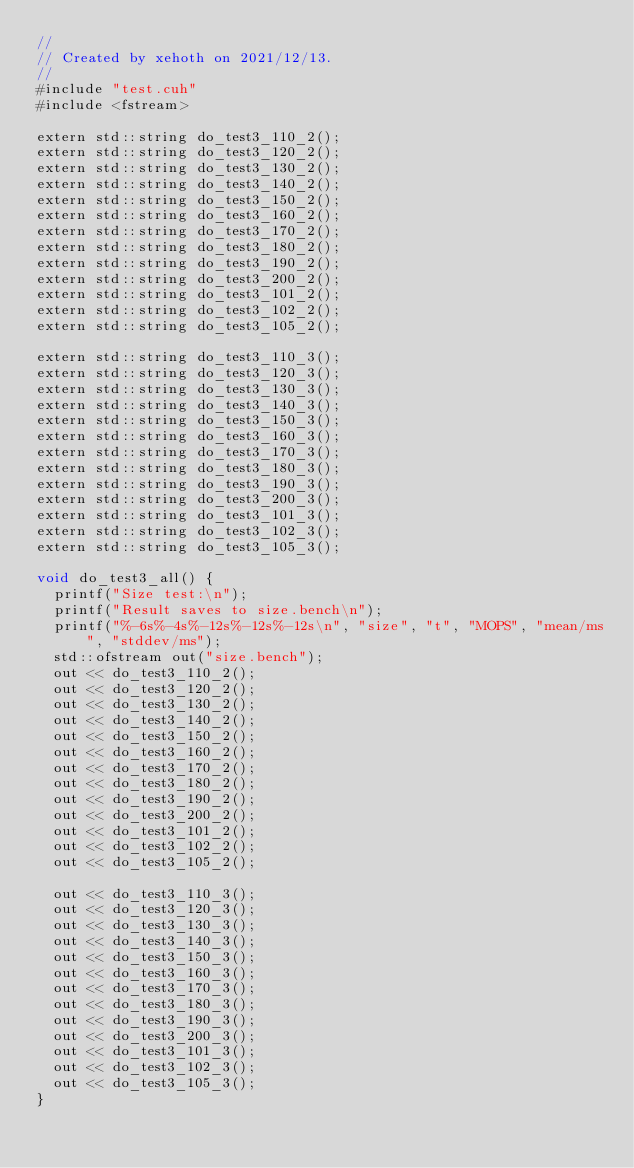Convert code to text. <code><loc_0><loc_0><loc_500><loc_500><_Cuda_>//
// Created by xehoth on 2021/12/13.
//
#include "test.cuh"
#include <fstream>

extern std::string do_test3_110_2();
extern std::string do_test3_120_2();
extern std::string do_test3_130_2();
extern std::string do_test3_140_2();
extern std::string do_test3_150_2();
extern std::string do_test3_160_2();
extern std::string do_test3_170_2();
extern std::string do_test3_180_2();
extern std::string do_test3_190_2();
extern std::string do_test3_200_2();
extern std::string do_test3_101_2();
extern std::string do_test3_102_2();
extern std::string do_test3_105_2();

extern std::string do_test3_110_3();
extern std::string do_test3_120_3();
extern std::string do_test3_130_3();
extern std::string do_test3_140_3();
extern std::string do_test3_150_3();
extern std::string do_test3_160_3();
extern std::string do_test3_170_3();
extern std::string do_test3_180_3();
extern std::string do_test3_190_3();
extern std::string do_test3_200_3();
extern std::string do_test3_101_3();
extern std::string do_test3_102_3();
extern std::string do_test3_105_3();

void do_test3_all() {
  printf("Size test:\n");
  printf("Result saves to size.bench\n");
  printf("%-6s%-4s%-12s%-12s%-12s\n", "size", "t", "MOPS", "mean/ms", "stddev/ms");
  std::ofstream out("size.bench");
  out << do_test3_110_2();
  out << do_test3_120_2();
  out << do_test3_130_2();
  out << do_test3_140_2();
  out << do_test3_150_2();
  out << do_test3_160_2();
  out << do_test3_170_2();
  out << do_test3_180_2();
  out << do_test3_190_2();
  out << do_test3_200_2();
  out << do_test3_101_2();
  out << do_test3_102_2();
  out << do_test3_105_2();

  out << do_test3_110_3();
  out << do_test3_120_3();
  out << do_test3_130_3();
  out << do_test3_140_3();
  out << do_test3_150_3();
  out << do_test3_160_3();
  out << do_test3_170_3();
  out << do_test3_180_3();
  out << do_test3_190_3();
  out << do_test3_200_3();
  out << do_test3_101_3();
  out << do_test3_102_3();
  out << do_test3_105_3();
}
</code> 